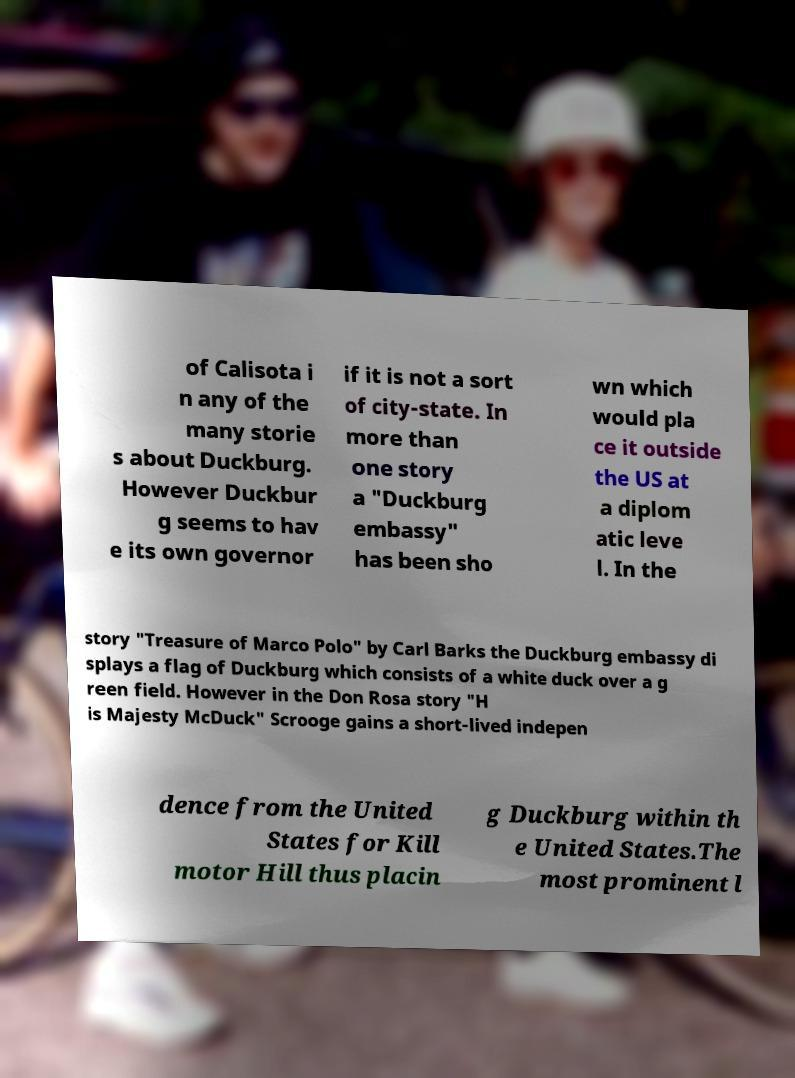What messages or text are displayed in this image? I need them in a readable, typed format. of Calisota i n any of the many storie s about Duckburg. However Duckbur g seems to hav e its own governor if it is not a sort of city-state. In more than one story a "Duckburg embassy" has been sho wn which would pla ce it outside the US at a diplom atic leve l. In the story "Treasure of Marco Polo" by Carl Barks the Duckburg embassy di splays a flag of Duckburg which consists of a white duck over a g reen field. However in the Don Rosa story "H is Majesty McDuck" Scrooge gains a short-lived indepen dence from the United States for Kill motor Hill thus placin g Duckburg within th e United States.The most prominent l 